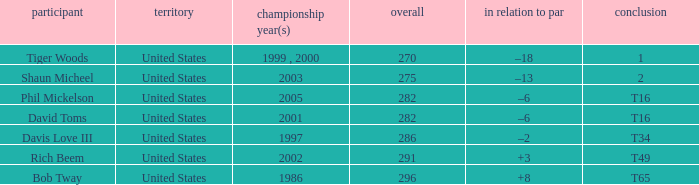What is Davis Love III's total? 286.0. 